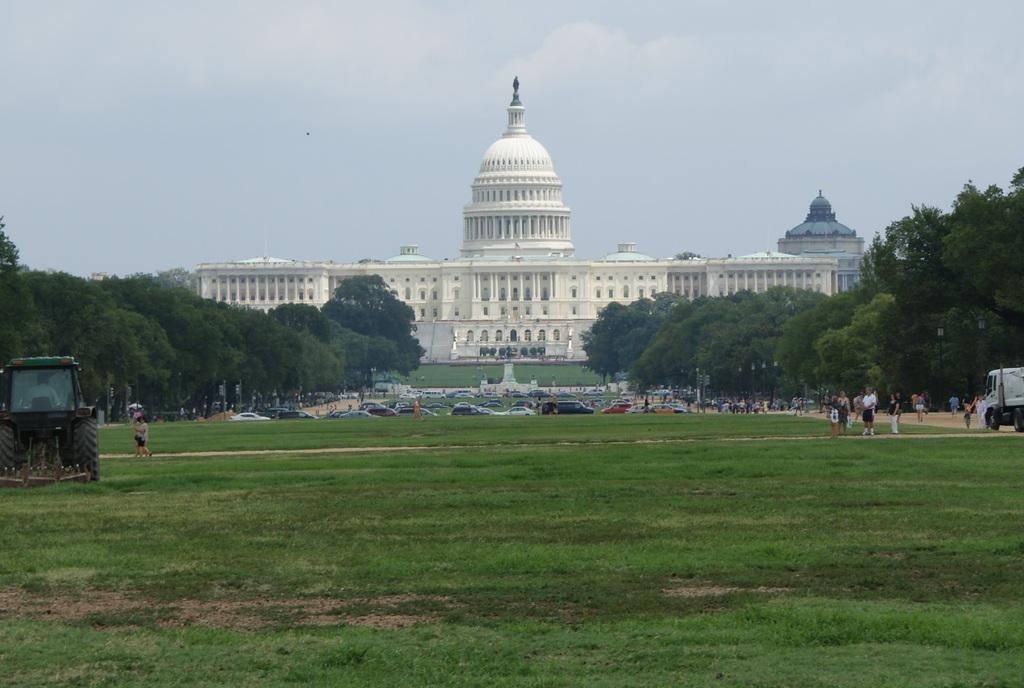Can you describe this image briefly? In this image there is a building, there is sky, there are treeś, there are people, there is grass, there is vehicle. 